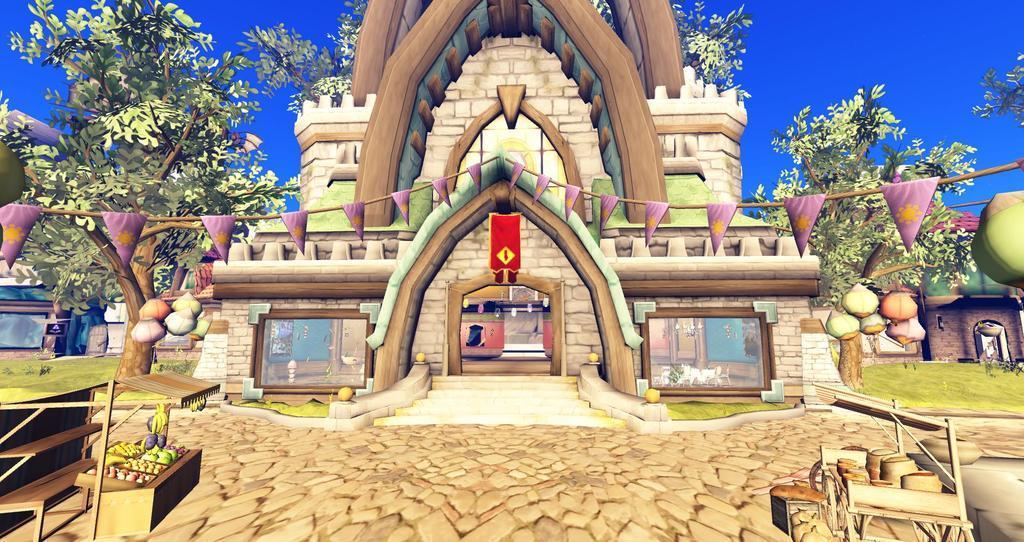Can you describe this image briefly? This is an animated image. We can see a few houses. There are some trees. We can see some flags and tables with objects. We can also see the ground. There are frames on one the houses. We can see the sky. 